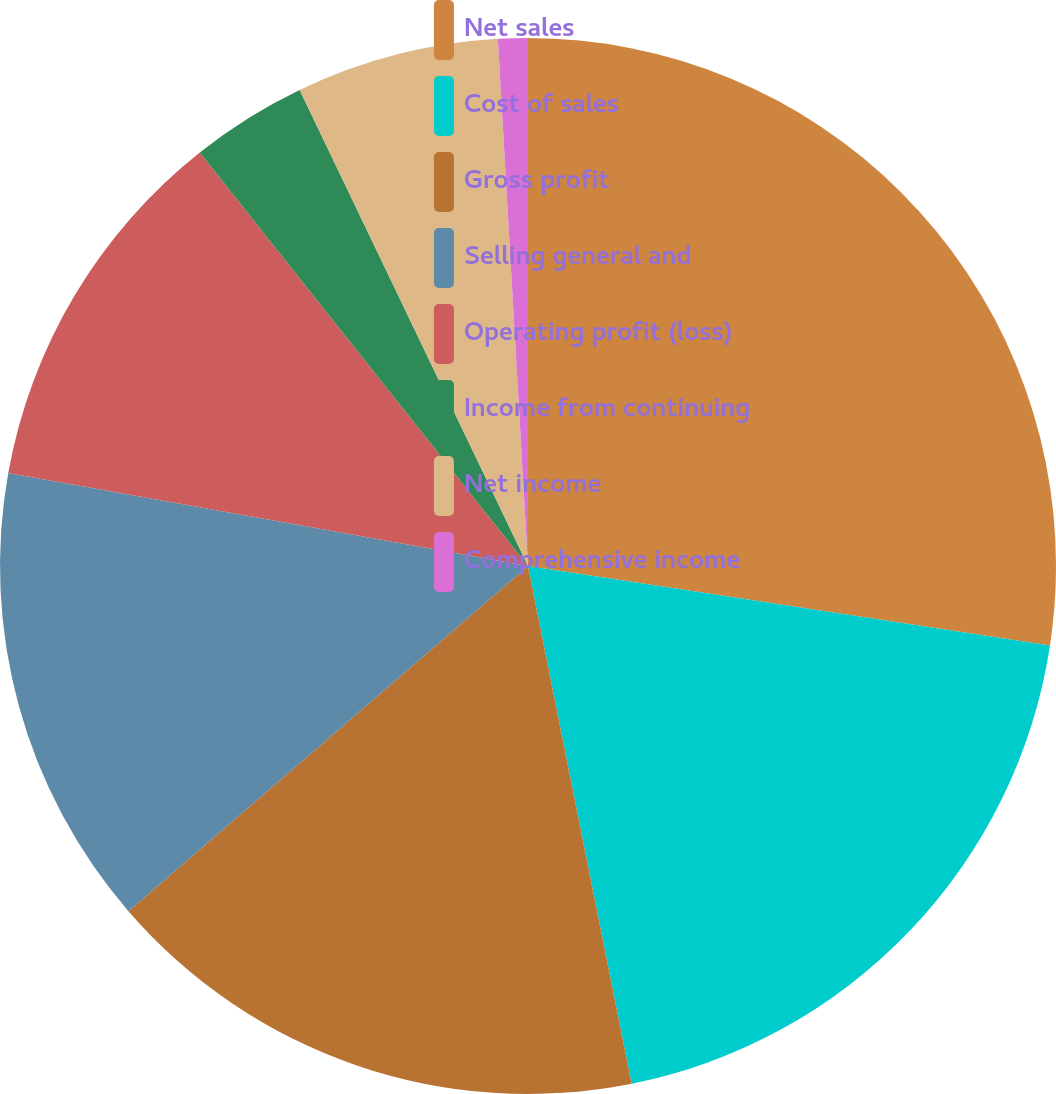Convert chart to OTSL. <chart><loc_0><loc_0><loc_500><loc_500><pie_chart><fcel>Net sales<fcel>Cost of sales<fcel>Gross profit<fcel>Selling general and<fcel>Operating profit (loss)<fcel>Income from continuing<fcel>Net income<fcel>Comprehensive income<nl><fcel>27.41%<fcel>19.46%<fcel>16.81%<fcel>14.16%<fcel>11.51%<fcel>3.56%<fcel>6.21%<fcel>0.91%<nl></chart> 